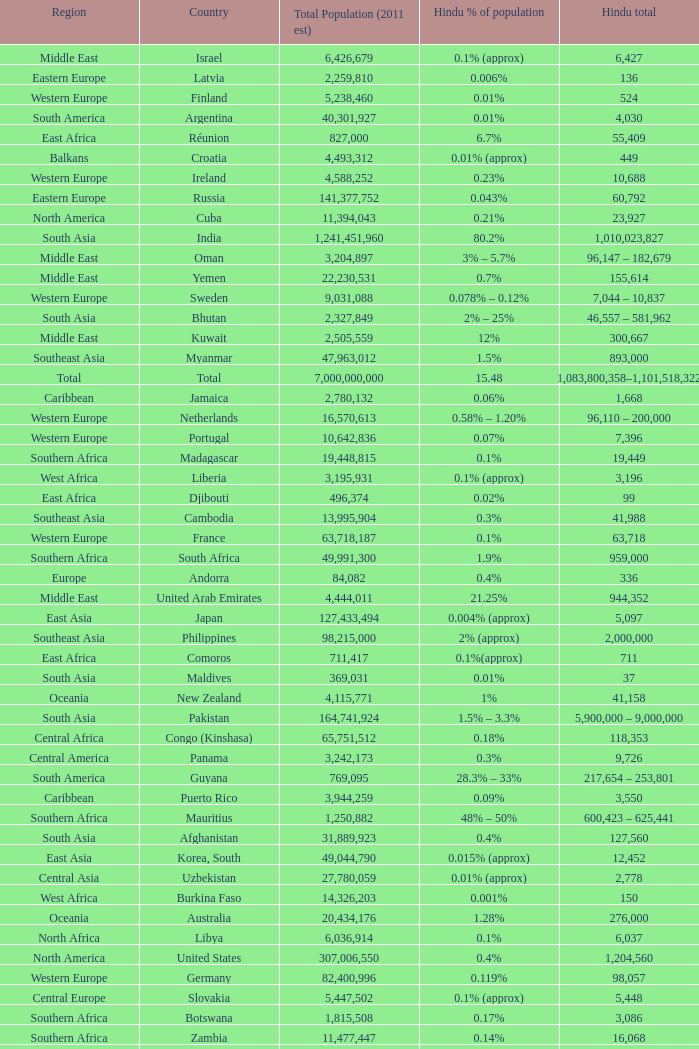Total Population (2011 est) larger than 30,262,610, and a Hindu total of 63,718 involves what country? France. 